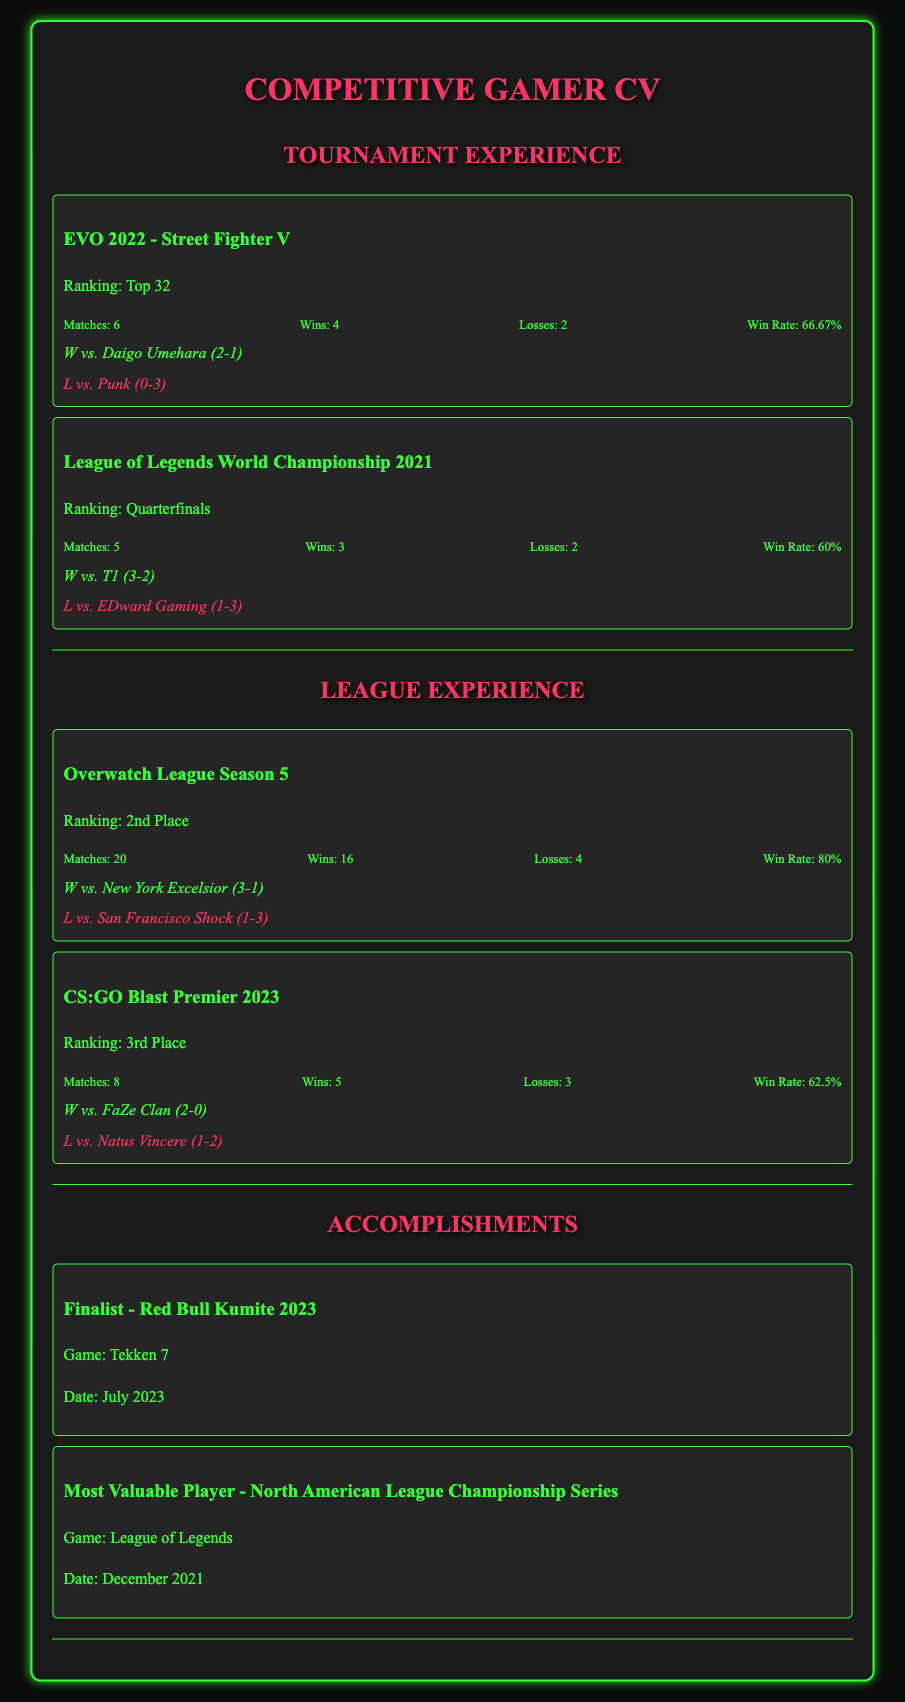what was the ranking in EVO 2022? The ranking in EVO 2022 is mentioned in the tournament section, which states "Ranking: Top 32".
Answer: Top 32 how many matches were played in the Overwatch League Season 5? The number of matches played in Overwatch League Season 5 is recorded in the league section, which states "Matches: 20".
Answer: 20 what is the win rate in League of Legends World Championship 2021? The win rate for League of Legends World Championship 2021 is specified in the tournament section as "Win Rate: 60%".
Answer: 60% which match was a notable win in CS:GO Blast Premier 2023? The notable win for CS:GO Blast Premier 2023 is highlighted in the league section stating "W vs. FaZe Clan (2-0)".
Answer: W vs. FaZe Clan (2-0) what accomplishment was achieved in July 2023? The accomplishment mentioned for July 2023 is specified as "Finalist - Red Bull Kumite 2023".
Answer: Finalist - Red Bull Kumite 2023 how many losses were recorded in Overwatch League Season 5? The number of losses in Overwatch League Season 5 is stated in the league section as "Losses: 4".
Answer: 4 what game was played in the North American League Championship Series MVP accomplishment? The game mentioned is "League of Legends".
Answer: League of Legends what was the win-loss record in EVO 2022? The win-loss record for EVO 2022 is presented in the stats as "Wins: 4" and "Losses: 2".
Answer: 4-2 what position was achieved in CS:GO Blast Premier 2023? The ranking achieved in CS:GO Blast Premier 2023 is "Ranking: 3rd Place".
Answer: 3rd Place 